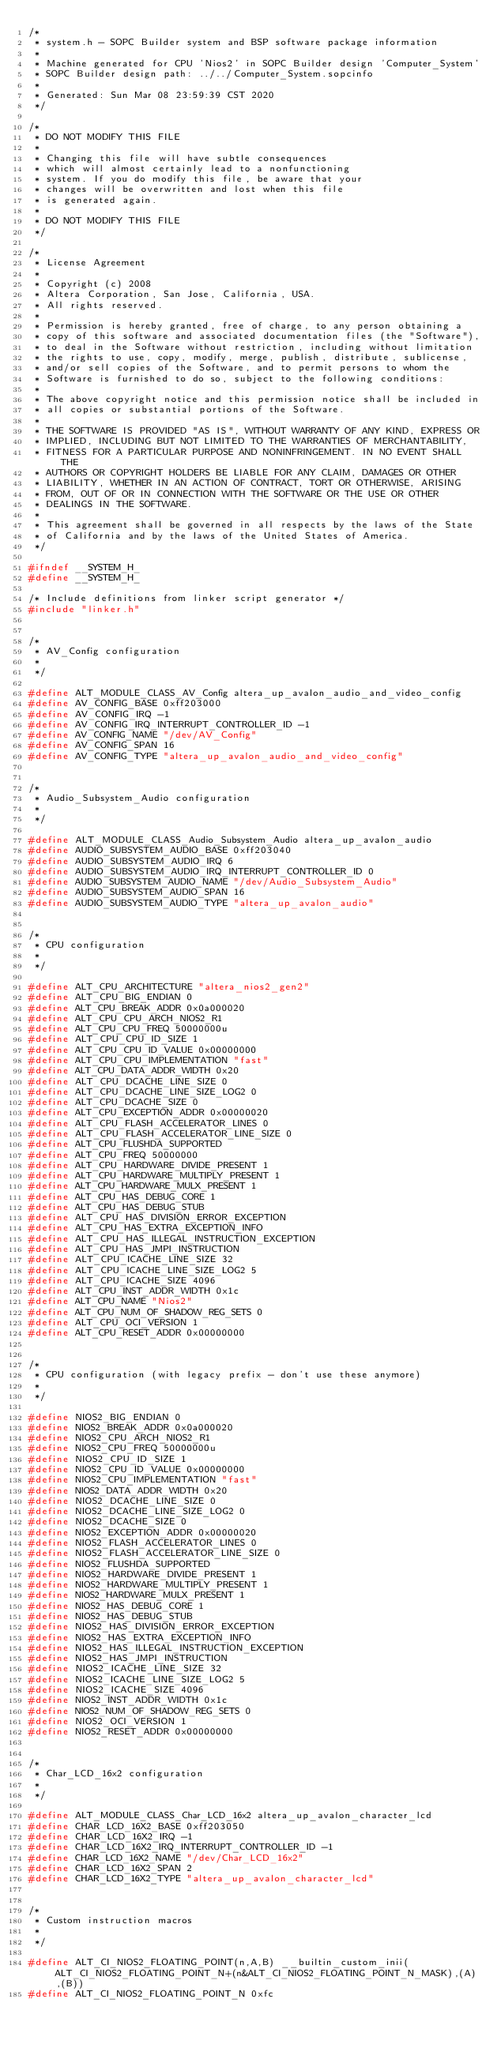Convert code to text. <code><loc_0><loc_0><loc_500><loc_500><_C_>/*
 * system.h - SOPC Builder system and BSP software package information
 *
 * Machine generated for CPU 'Nios2' in SOPC Builder design 'Computer_System'
 * SOPC Builder design path: ../../Computer_System.sopcinfo
 *
 * Generated: Sun Mar 08 23:59:39 CST 2020
 */

/*
 * DO NOT MODIFY THIS FILE
 *
 * Changing this file will have subtle consequences
 * which will almost certainly lead to a nonfunctioning
 * system. If you do modify this file, be aware that your
 * changes will be overwritten and lost when this file
 * is generated again.
 *
 * DO NOT MODIFY THIS FILE
 */

/*
 * License Agreement
 *
 * Copyright (c) 2008
 * Altera Corporation, San Jose, California, USA.
 * All rights reserved.
 *
 * Permission is hereby granted, free of charge, to any person obtaining a
 * copy of this software and associated documentation files (the "Software"),
 * to deal in the Software without restriction, including without limitation
 * the rights to use, copy, modify, merge, publish, distribute, sublicense,
 * and/or sell copies of the Software, and to permit persons to whom the
 * Software is furnished to do so, subject to the following conditions:
 *
 * The above copyright notice and this permission notice shall be included in
 * all copies or substantial portions of the Software.
 *
 * THE SOFTWARE IS PROVIDED "AS IS", WITHOUT WARRANTY OF ANY KIND, EXPRESS OR
 * IMPLIED, INCLUDING BUT NOT LIMITED TO THE WARRANTIES OF MERCHANTABILITY,
 * FITNESS FOR A PARTICULAR PURPOSE AND NONINFRINGEMENT. IN NO EVENT SHALL THE
 * AUTHORS OR COPYRIGHT HOLDERS BE LIABLE FOR ANY CLAIM, DAMAGES OR OTHER
 * LIABILITY, WHETHER IN AN ACTION OF CONTRACT, TORT OR OTHERWISE, ARISING
 * FROM, OUT OF OR IN CONNECTION WITH THE SOFTWARE OR THE USE OR OTHER
 * DEALINGS IN THE SOFTWARE.
 *
 * This agreement shall be governed in all respects by the laws of the State
 * of California and by the laws of the United States of America.
 */

#ifndef __SYSTEM_H_
#define __SYSTEM_H_

/* Include definitions from linker script generator */
#include "linker.h"


/*
 * AV_Config configuration
 *
 */

#define ALT_MODULE_CLASS_AV_Config altera_up_avalon_audio_and_video_config
#define AV_CONFIG_BASE 0xff203000
#define AV_CONFIG_IRQ -1
#define AV_CONFIG_IRQ_INTERRUPT_CONTROLLER_ID -1
#define AV_CONFIG_NAME "/dev/AV_Config"
#define AV_CONFIG_SPAN 16
#define AV_CONFIG_TYPE "altera_up_avalon_audio_and_video_config"


/*
 * Audio_Subsystem_Audio configuration
 *
 */

#define ALT_MODULE_CLASS_Audio_Subsystem_Audio altera_up_avalon_audio
#define AUDIO_SUBSYSTEM_AUDIO_BASE 0xff203040
#define AUDIO_SUBSYSTEM_AUDIO_IRQ 6
#define AUDIO_SUBSYSTEM_AUDIO_IRQ_INTERRUPT_CONTROLLER_ID 0
#define AUDIO_SUBSYSTEM_AUDIO_NAME "/dev/Audio_Subsystem_Audio"
#define AUDIO_SUBSYSTEM_AUDIO_SPAN 16
#define AUDIO_SUBSYSTEM_AUDIO_TYPE "altera_up_avalon_audio"


/*
 * CPU configuration
 *
 */

#define ALT_CPU_ARCHITECTURE "altera_nios2_gen2"
#define ALT_CPU_BIG_ENDIAN 0
#define ALT_CPU_BREAK_ADDR 0x0a000020
#define ALT_CPU_CPU_ARCH_NIOS2_R1
#define ALT_CPU_CPU_FREQ 50000000u
#define ALT_CPU_CPU_ID_SIZE 1
#define ALT_CPU_CPU_ID_VALUE 0x00000000
#define ALT_CPU_CPU_IMPLEMENTATION "fast"
#define ALT_CPU_DATA_ADDR_WIDTH 0x20
#define ALT_CPU_DCACHE_LINE_SIZE 0
#define ALT_CPU_DCACHE_LINE_SIZE_LOG2 0
#define ALT_CPU_DCACHE_SIZE 0
#define ALT_CPU_EXCEPTION_ADDR 0x00000020
#define ALT_CPU_FLASH_ACCELERATOR_LINES 0
#define ALT_CPU_FLASH_ACCELERATOR_LINE_SIZE 0
#define ALT_CPU_FLUSHDA_SUPPORTED
#define ALT_CPU_FREQ 50000000
#define ALT_CPU_HARDWARE_DIVIDE_PRESENT 1
#define ALT_CPU_HARDWARE_MULTIPLY_PRESENT 1
#define ALT_CPU_HARDWARE_MULX_PRESENT 1
#define ALT_CPU_HAS_DEBUG_CORE 1
#define ALT_CPU_HAS_DEBUG_STUB
#define ALT_CPU_HAS_DIVISION_ERROR_EXCEPTION
#define ALT_CPU_HAS_EXTRA_EXCEPTION_INFO
#define ALT_CPU_HAS_ILLEGAL_INSTRUCTION_EXCEPTION
#define ALT_CPU_HAS_JMPI_INSTRUCTION
#define ALT_CPU_ICACHE_LINE_SIZE 32
#define ALT_CPU_ICACHE_LINE_SIZE_LOG2 5
#define ALT_CPU_ICACHE_SIZE 4096
#define ALT_CPU_INST_ADDR_WIDTH 0x1c
#define ALT_CPU_NAME "Nios2"
#define ALT_CPU_NUM_OF_SHADOW_REG_SETS 0
#define ALT_CPU_OCI_VERSION 1
#define ALT_CPU_RESET_ADDR 0x00000000


/*
 * CPU configuration (with legacy prefix - don't use these anymore)
 *
 */

#define NIOS2_BIG_ENDIAN 0
#define NIOS2_BREAK_ADDR 0x0a000020
#define NIOS2_CPU_ARCH_NIOS2_R1
#define NIOS2_CPU_FREQ 50000000u
#define NIOS2_CPU_ID_SIZE 1
#define NIOS2_CPU_ID_VALUE 0x00000000
#define NIOS2_CPU_IMPLEMENTATION "fast"
#define NIOS2_DATA_ADDR_WIDTH 0x20
#define NIOS2_DCACHE_LINE_SIZE 0
#define NIOS2_DCACHE_LINE_SIZE_LOG2 0
#define NIOS2_DCACHE_SIZE 0
#define NIOS2_EXCEPTION_ADDR 0x00000020
#define NIOS2_FLASH_ACCELERATOR_LINES 0
#define NIOS2_FLASH_ACCELERATOR_LINE_SIZE 0
#define NIOS2_FLUSHDA_SUPPORTED
#define NIOS2_HARDWARE_DIVIDE_PRESENT 1
#define NIOS2_HARDWARE_MULTIPLY_PRESENT 1
#define NIOS2_HARDWARE_MULX_PRESENT 1
#define NIOS2_HAS_DEBUG_CORE 1
#define NIOS2_HAS_DEBUG_STUB
#define NIOS2_HAS_DIVISION_ERROR_EXCEPTION
#define NIOS2_HAS_EXTRA_EXCEPTION_INFO
#define NIOS2_HAS_ILLEGAL_INSTRUCTION_EXCEPTION
#define NIOS2_HAS_JMPI_INSTRUCTION
#define NIOS2_ICACHE_LINE_SIZE 32
#define NIOS2_ICACHE_LINE_SIZE_LOG2 5
#define NIOS2_ICACHE_SIZE 4096
#define NIOS2_INST_ADDR_WIDTH 0x1c
#define NIOS2_NUM_OF_SHADOW_REG_SETS 0
#define NIOS2_OCI_VERSION 1
#define NIOS2_RESET_ADDR 0x00000000


/*
 * Char_LCD_16x2 configuration
 *
 */

#define ALT_MODULE_CLASS_Char_LCD_16x2 altera_up_avalon_character_lcd
#define CHAR_LCD_16X2_BASE 0xff203050
#define CHAR_LCD_16X2_IRQ -1
#define CHAR_LCD_16X2_IRQ_INTERRUPT_CONTROLLER_ID -1
#define CHAR_LCD_16X2_NAME "/dev/Char_LCD_16x2"
#define CHAR_LCD_16X2_SPAN 2
#define CHAR_LCD_16X2_TYPE "altera_up_avalon_character_lcd"


/*
 * Custom instruction macros
 *
 */

#define ALT_CI_NIOS2_FLOATING_POINT(n,A,B) __builtin_custom_inii(ALT_CI_NIOS2_FLOATING_POINT_N+(n&ALT_CI_NIOS2_FLOATING_POINT_N_MASK),(A),(B))
#define ALT_CI_NIOS2_FLOATING_POINT_N 0xfc</code> 